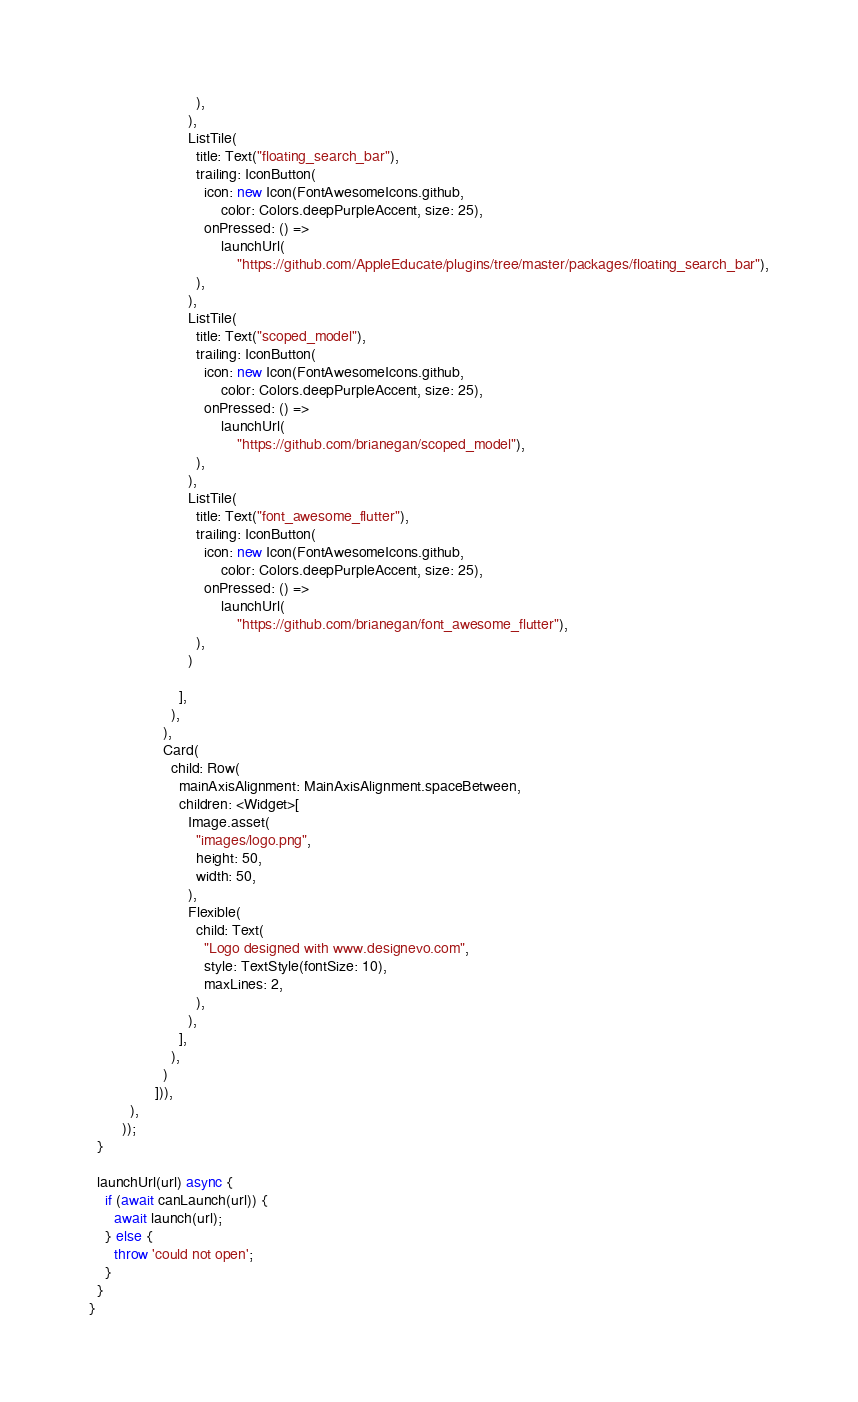<code> <loc_0><loc_0><loc_500><loc_500><_Dart_>                          ),
                        ),
                        ListTile(
                          title: Text("floating_search_bar"),
                          trailing: IconButton(
                            icon: new Icon(FontAwesomeIcons.github,
                                color: Colors.deepPurpleAccent, size: 25),
                            onPressed: () =>
                                launchUrl(
                                    "https://github.com/AppleEducate/plugins/tree/master/packages/floating_search_bar"),
                          ),
                        ),
                        ListTile(
                          title: Text("scoped_model"),
                          trailing: IconButton(
                            icon: new Icon(FontAwesomeIcons.github,
                                color: Colors.deepPurpleAccent, size: 25),
                            onPressed: () =>
                                launchUrl(
                                    "https://github.com/brianegan/scoped_model"),
                          ),
                        ),
                        ListTile(
                          title: Text("font_awesome_flutter"),
                          trailing: IconButton(
                            icon: new Icon(FontAwesomeIcons.github,
                                color: Colors.deepPurpleAccent, size: 25),
                            onPressed: () =>
                                launchUrl(
                                    "https://github.com/brianegan/font_awesome_flutter"),
                          ),
                        )

                      ],
                    ),
                  ),
                  Card(
                    child: Row(
                      mainAxisAlignment: MainAxisAlignment.spaceBetween,
                      children: <Widget>[
                        Image.asset(
                          "images/logo.png",
                          height: 50,
                          width: 50,
                        ),
                        Flexible(
                          child: Text(
                            "Logo designed with www.designevo.com",
                            style: TextStyle(fontSize: 10),
                            maxLines: 2,
                          ),
                        ),
                      ],
                    ),
                  )
                ])),
          ),
        ));
  }

  launchUrl(url) async {
    if (await canLaunch(url)) {
      await launch(url);
    } else {
      throw 'could not open';
    }
  }
}
</code> 